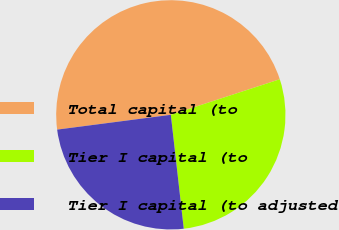<chart> <loc_0><loc_0><loc_500><loc_500><pie_chart><fcel>Total capital (to<fcel>Tier I capital (to<fcel>Tier I capital (to adjusted<nl><fcel>47.04%<fcel>28.22%<fcel>24.74%<nl></chart> 